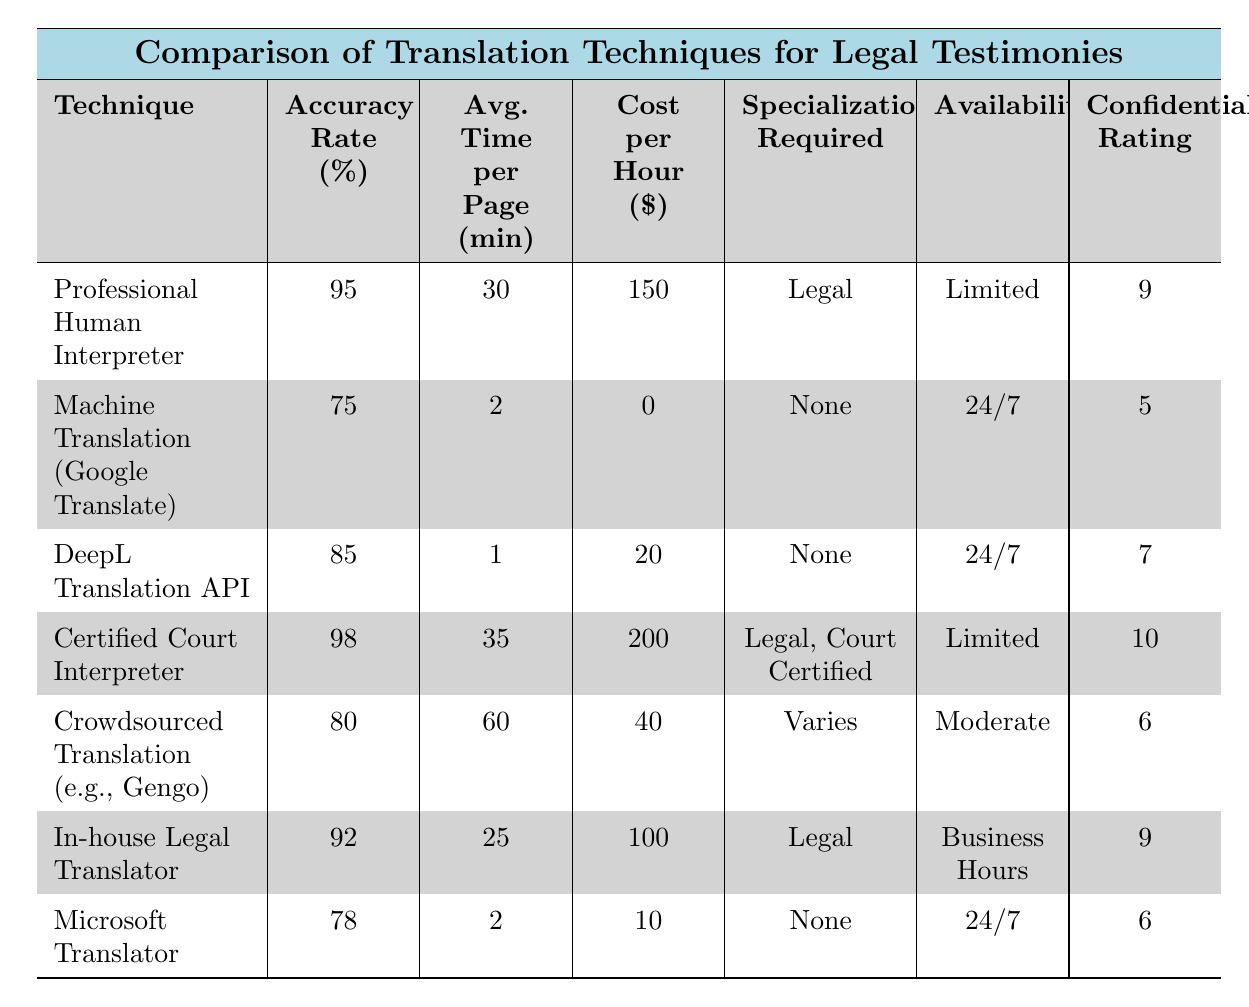What is the accuracy rate of the Certified Court Interpreter? The accuracy rate of the Certified Court Interpreter is shown in the table as 98%.
Answer: 98% Which translation technique requires legal specialization? The table lists Professional Human Interpreter, Certified Court Interpreter, and In-house Legal Translator as techniques that require legal specialization.
Answer: Professional Human Interpreter, Certified Court Interpreter, In-house Legal Translator What is the average time per page for Machine Translation (Google Translate)? The table specifies that the average time per page for Machine Translation (Google Translate) is 2 minutes.
Answer: 2 minutes Which translation technique has the highest confidentiality rating? From the table, the Certified Court Interpreter has the highest confidentiality rating of 10.
Answer: 10 What is the cost per hour of using an In-house Legal Translator? The cost per hour for an In-house Legal Translator is given in the table as 100 dollars.
Answer: 100 dollars How does the accuracy rate of DeepL Translation API compare to that of Microsoft Translator? The accuracy rate of DeepL Translation API is 85%, whereas Microsoft Translator has an accuracy rate of 78%. To compare, 85% is higher than 78%.
Answer: DeepL Translation API is higher What is the average accuracy rate of all techniques listed in the table? To find the average accuracy rate, sum all the accuracy rates: (95 + 75 + 85 + 98 + 80 + 92 + 78) = 703. There are 7 techniques, so the average is 703 / 7 = 100.43.
Answer: 100.43 Is it true that Machine Translation (Google Translate) is available 24/7? The table states that Machine Translation (Google Translate) is available 24/7, confirming the fact to be true.
Answer: Yes Which translation technique takes the longest time per page, and how much time is it? The table indicates that Crowdsourced Translation (e.g., Gengo) takes the longest time per page at 60 minutes.
Answer: Crowdsourced Translation, 60 minutes How many techniques have an accuracy rate above 90%? The techniques with an accuracy rate above 90% are the Certified Court Interpreter (98%), Professional Human Interpreter (95%), and In-house Legal Translator (92%). This totals to three techniques.
Answer: Three techniques 